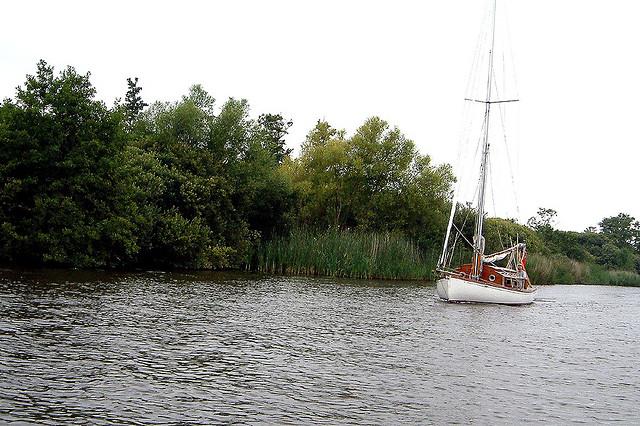How many boats are on the water?
Keep it brief. 1. Is that water safe to drink?
Be succinct. No. Was the photo taken in the daytime?
Concise answer only. Yes. Are there balloons on the white boat?
Write a very short answer. No. Is the sail unfurled?
Short answer required. No. 